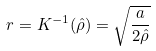<formula> <loc_0><loc_0><loc_500><loc_500>r = K ^ { - 1 } ( \hat { \rho } ) = \sqrt { \frac { a } { 2 \hat { \rho } } }</formula> 